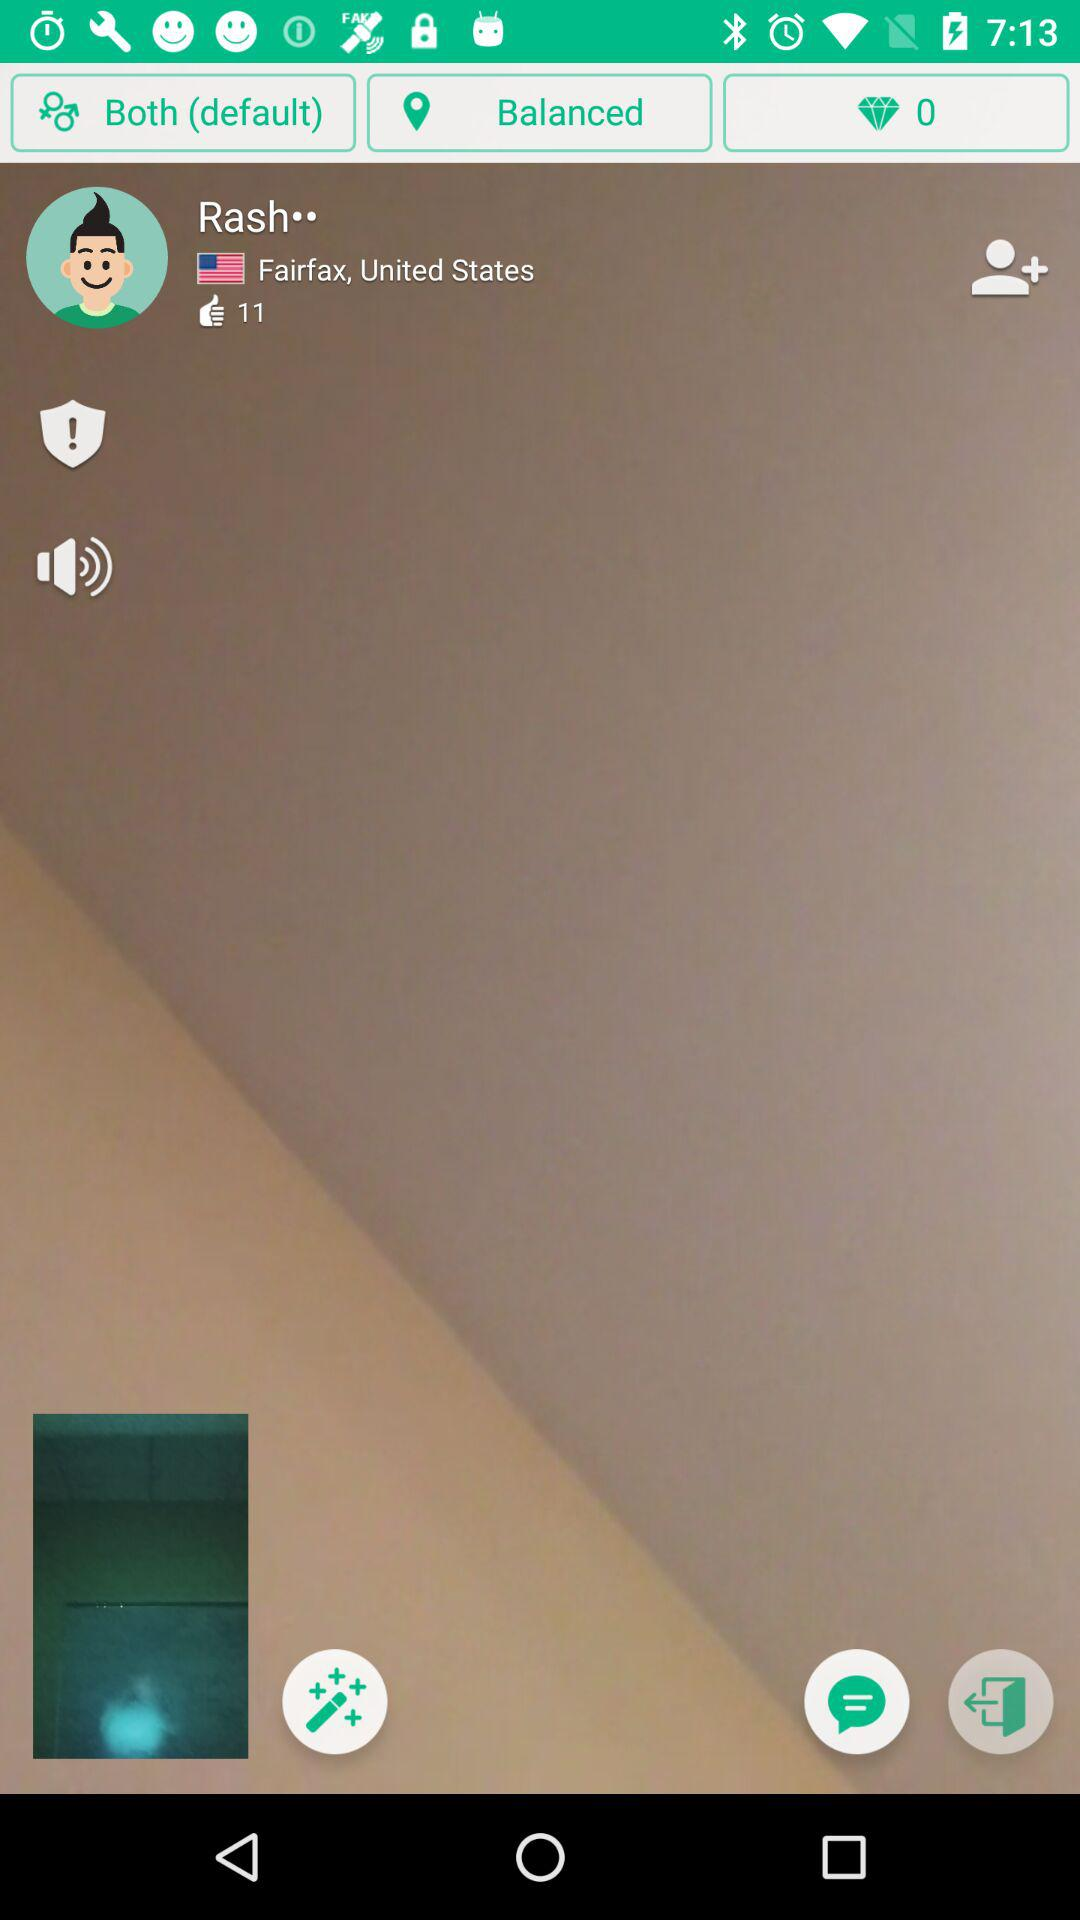Where is the location of Rash? The location of the rash is Fairfax, United States. 